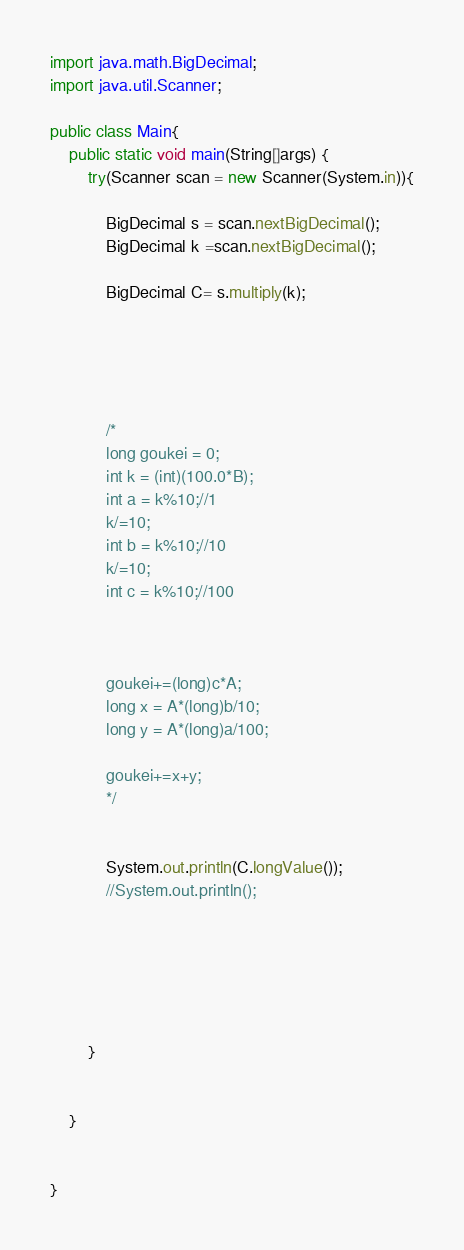<code> <loc_0><loc_0><loc_500><loc_500><_Java_>import java.math.BigDecimal;
import java.util.Scanner;

public class Main{
	public static void main(String[]args) {
		try(Scanner scan = new Scanner(System.in)){
			
			BigDecimal s = scan.nextBigDecimal();
			BigDecimal k =scan.nextBigDecimal();
			
			BigDecimal C= s.multiply(k);
			
			
		
			
			
			/*
			long goukei = 0;
			int k = (int)(100.0*B);
			int a = k%10;//1
			k/=10;
			int b = k%10;//10
			k/=10;
			int c = k%10;//100
			
			
			
			goukei+=(long)c*A;
			long x = A*(long)b/10;
			long y = A*(long)a/100;
			
			goukei+=x+y;
			*/
			
	
			System.out.println(C.longValue());
			//System.out.println();
			
			
			
			
			
			
		}
		
		
	}
		

}
</code> 